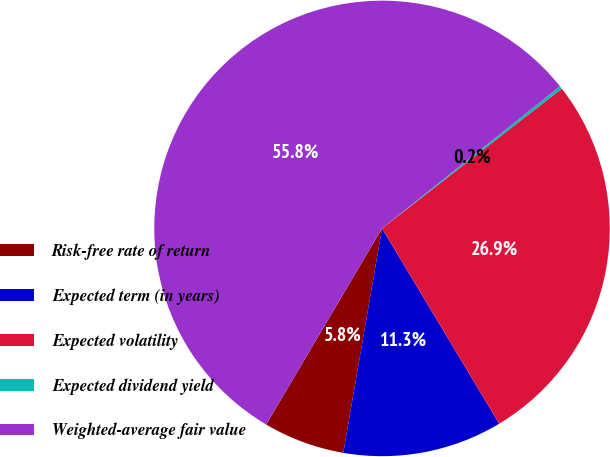Convert chart. <chart><loc_0><loc_0><loc_500><loc_500><pie_chart><fcel>Risk-free rate of return<fcel>Expected term (in years)<fcel>Expected volatility<fcel>Expected dividend yield<fcel>Weighted-average fair value<nl><fcel>5.77%<fcel>11.32%<fcel>26.92%<fcel>0.21%<fcel>55.78%<nl></chart> 